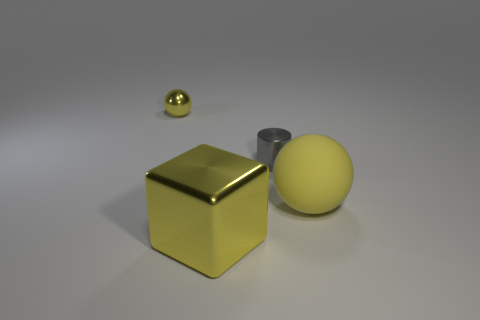The matte ball that is the same color as the big cube is what size?
Offer a very short reply. Large. How many yellow things are behind the big yellow ball and in front of the gray metallic object?
Keep it short and to the point. 0. What number of rubber objects are yellow balls or blue spheres?
Give a very brief answer. 1. What is the size of the yellow metallic object behind the big yellow thing on the left side of the large rubber object?
Offer a terse response. Small. There is a tiny sphere that is the same color as the metallic cube; what material is it?
Make the answer very short. Metal. Is there a matte ball that is in front of the yellow metallic object that is to the right of the yellow object that is behind the tiny gray shiny cylinder?
Give a very brief answer. No. Do the big yellow object that is on the right side of the cylinder and the yellow object that is behind the small gray shiny thing have the same material?
Your answer should be very brief. No. What number of things are large shiny blocks or things on the left side of the gray metal object?
Ensure brevity in your answer.  2. What number of other big yellow objects are the same shape as the large metal thing?
Offer a terse response. 0. There is a ball that is the same size as the yellow cube; what is it made of?
Provide a succinct answer. Rubber. 